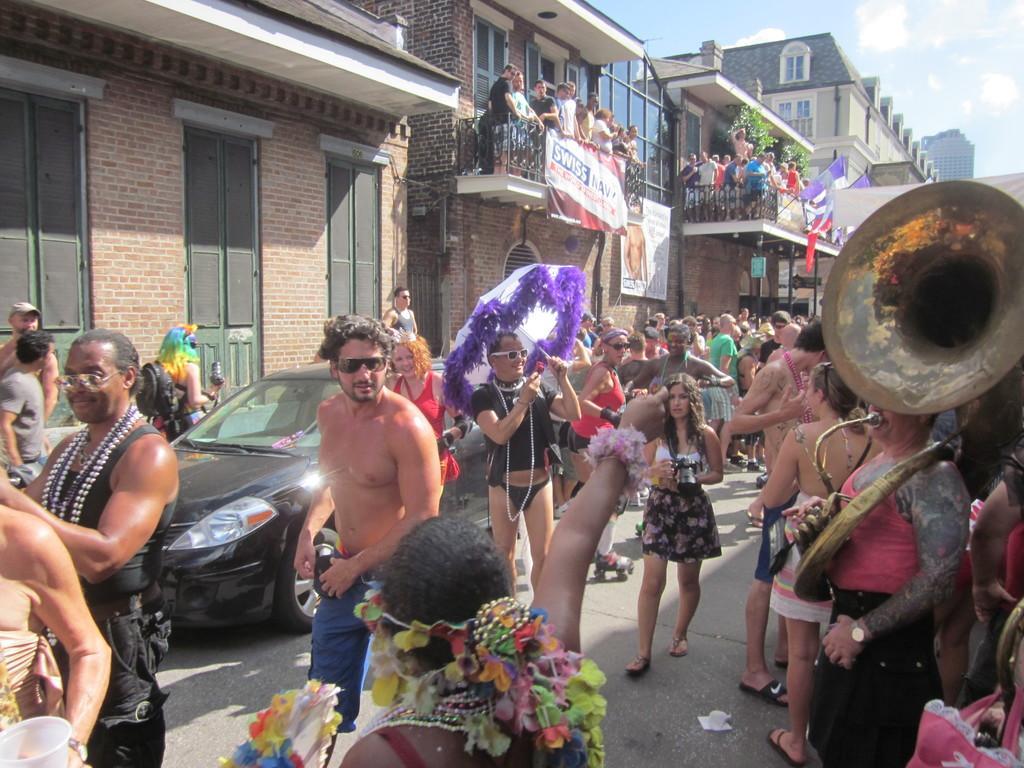How would you summarize this image in a sentence or two? In this picture we can observe some people walking on the road. There are men and women in this picture. We can observe a person holding an umbrella in his hand. There is a black color car on this road. We can observe buildings and a poster here. In the background there is a sky with some clouds here. 